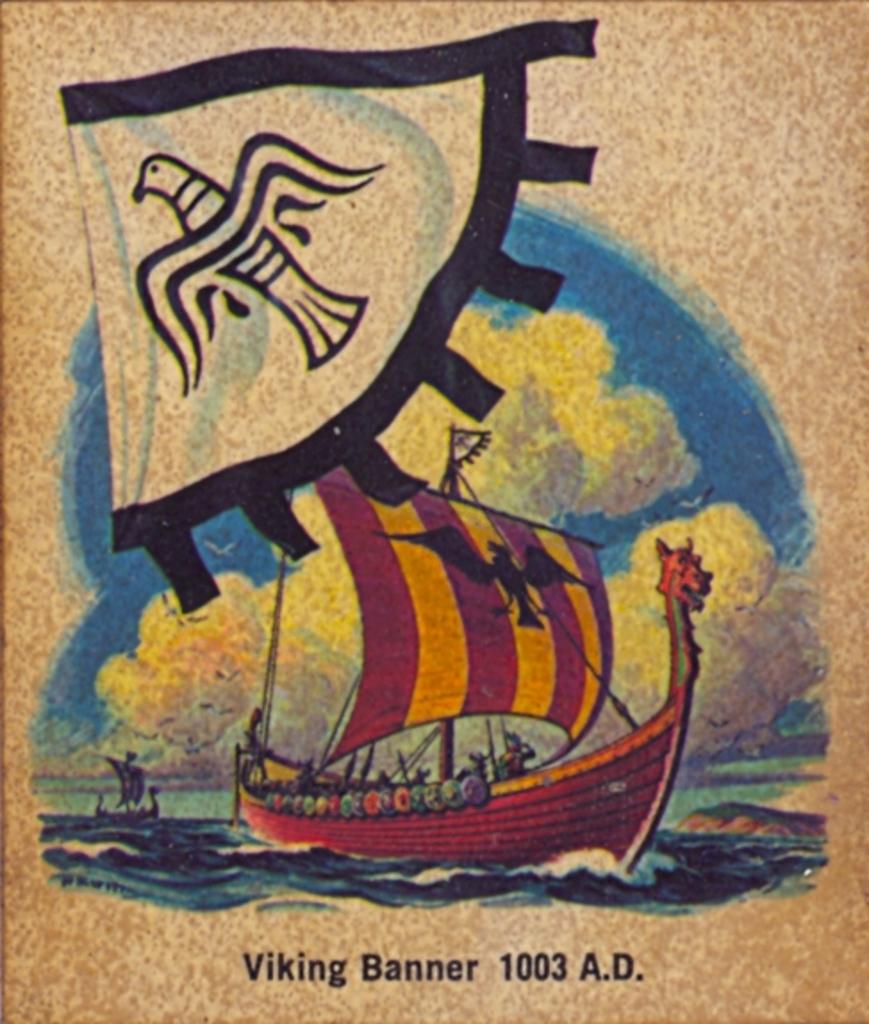When is the viking banner from?
Ensure brevity in your answer.  1003 a.d. What type of banner is shown?
Provide a short and direct response. Viking. 